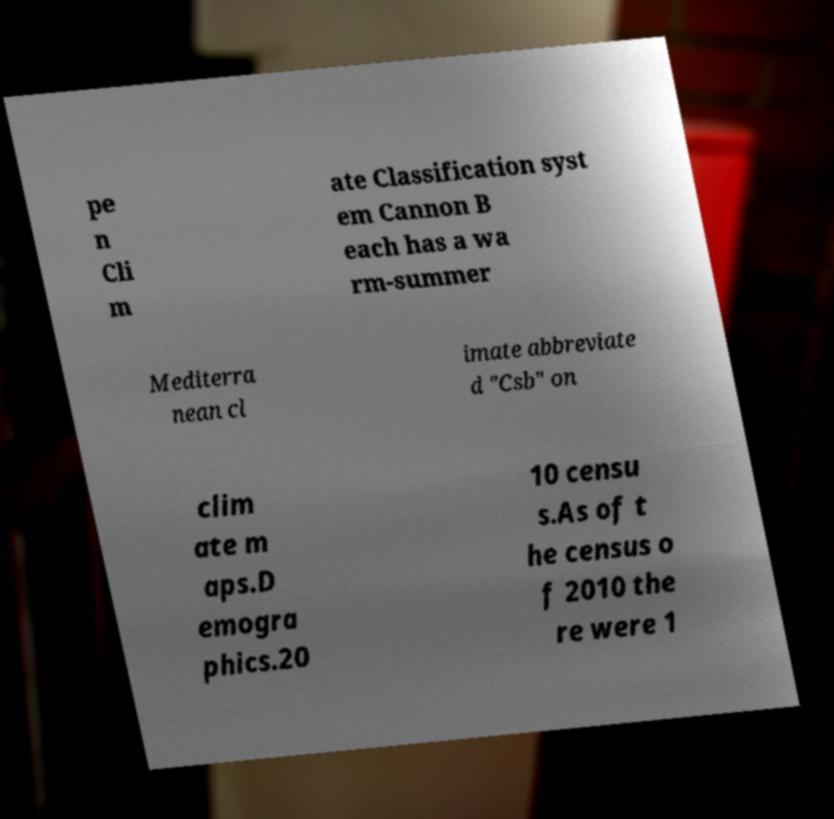I need the written content from this picture converted into text. Can you do that? pe n Cli m ate Classification syst em Cannon B each has a wa rm-summer Mediterra nean cl imate abbreviate d "Csb" on clim ate m aps.D emogra phics.20 10 censu s.As of t he census o f 2010 the re were 1 